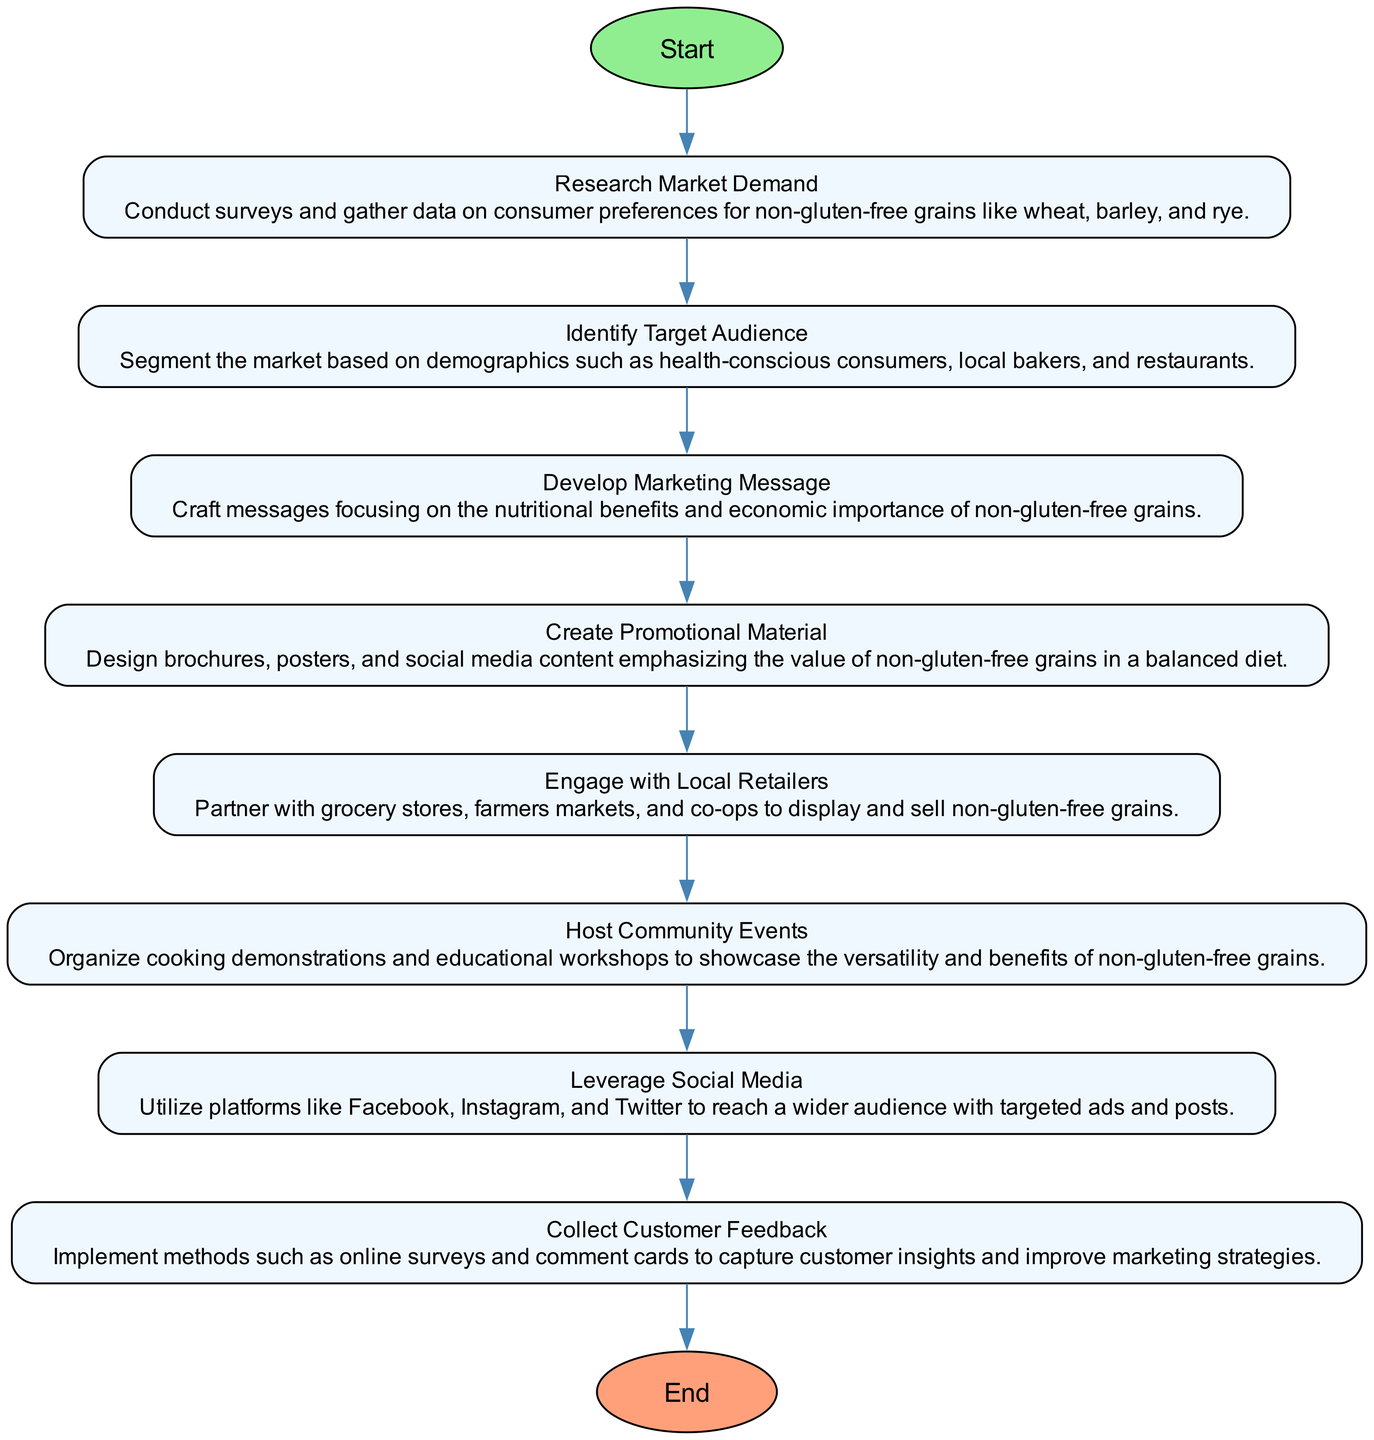What is the first step in the marketing strategy? The flowchart indicates that the first step is "Research Market Demand." This is based on the flow from the starting node to the first processing step in the diagram.
Answer: Research Market Demand How many total steps are there in the marketing strategy? The flowchart lists a total of eight steps, as represented by the nodes connected in sequence from the start to the end node.
Answer: Eight Which step involves creating brochures and social media content? The flowchart specifies that "Create Promotional Material" is the step where brochures and social media content are designed. This is directly stated in the corresponding node of the diagram.
Answer: Create Promotional Material What is the last step before reaching the end node? The final step before the end node is "Collect Customer Feedback." This is identified by tracing the flow from the last processing node before the end node in the diagram.
Answer: Collect Customer Feedback Which two steps are directly connected in the diagram? The steps "Develop Marketing Message" and "Create Promotional Material" are connected; there is an edge linking these two nodes, indicating the flow from one to the other.
Answer: Develop Marketing Message, Create Promotional Material What is the main target group mentioned in the "Identify Target Audience"? The "Identify Target Audience" step mentions segments like health-conscious consumers, local bakers, and restaurants. This information can be found in the details of the respective node.
Answer: Health-conscious consumers, local bakers, restaurants What action is taken in the step "Engage with Local Retailers"? The flowchart shows that in this step, the action is to partner with grocery stores, farmers markets, and co-ops to sell non-gluten-free grains. This is explicitly stated in the node details.
Answer: Partner What is a key benefit discussed in "Develop Marketing Message"? The key benefit mentioned when developing the marketing message focuses on the "nutritional benefits and economic importance" of non-gluten-free grains, stated clearly in the node details.
Answer: Nutritional benefits and economic importance How does the promotion strategy utilize social media? The flowchart indicates that social media is leveraged to reach a wider audience using targeted ads and posts, as outlined in the details of the "Leverage Social Media" step.
Answer: Targeted ads and posts 